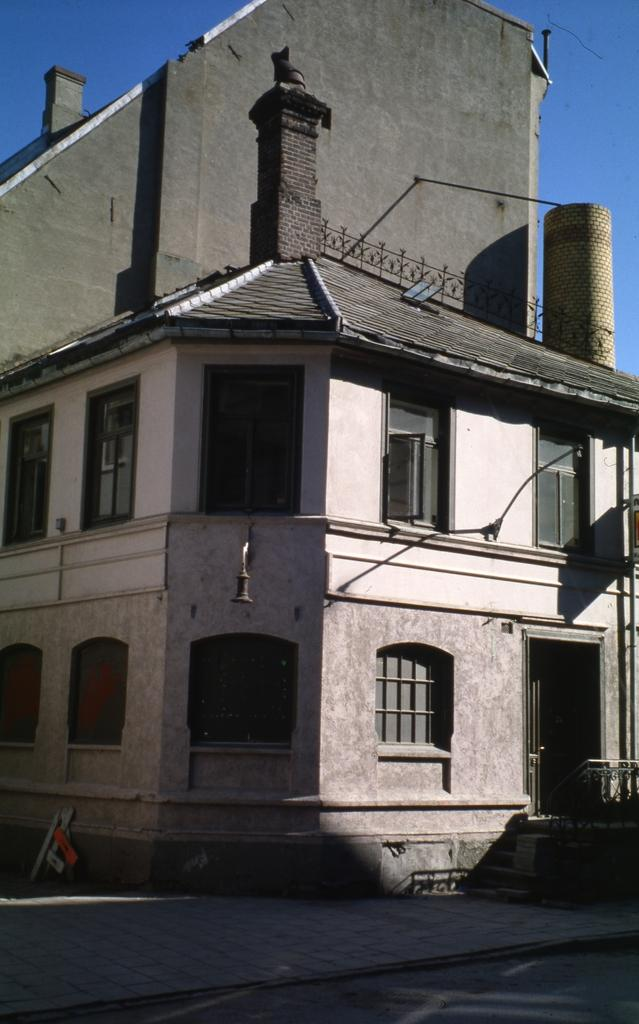What structure is the main subject of the image? There is a building in the image. What architectural feature is located in front of the building? There are stairs in front of the building. What part of the natural environment is visible in the image? The sky is visible at the back side of the image. Where are the books and sofa located in the image? There are no books or sofa present in the image. Can you tell me how many drawers are visible in the image? There are no drawers visible in the image. 